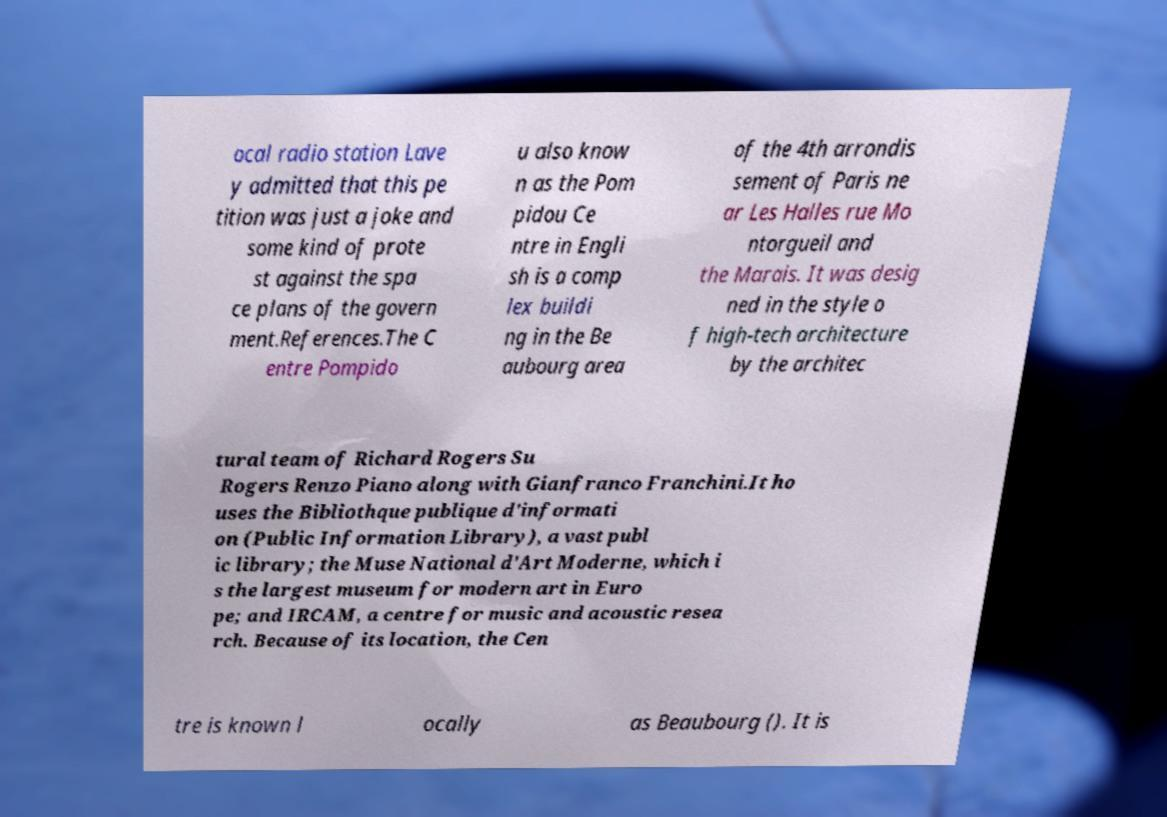Please identify and transcribe the text found in this image. ocal radio station Lave y admitted that this pe tition was just a joke and some kind of prote st against the spa ce plans of the govern ment.References.The C entre Pompido u also know n as the Pom pidou Ce ntre in Engli sh is a comp lex buildi ng in the Be aubourg area of the 4th arrondis sement of Paris ne ar Les Halles rue Mo ntorgueil and the Marais. It was desig ned in the style o f high-tech architecture by the architec tural team of Richard Rogers Su Rogers Renzo Piano along with Gianfranco Franchini.It ho uses the Bibliothque publique d'informati on (Public Information Library), a vast publ ic library; the Muse National d'Art Moderne, which i s the largest museum for modern art in Euro pe; and IRCAM, a centre for music and acoustic resea rch. Because of its location, the Cen tre is known l ocally as Beaubourg (). It is 